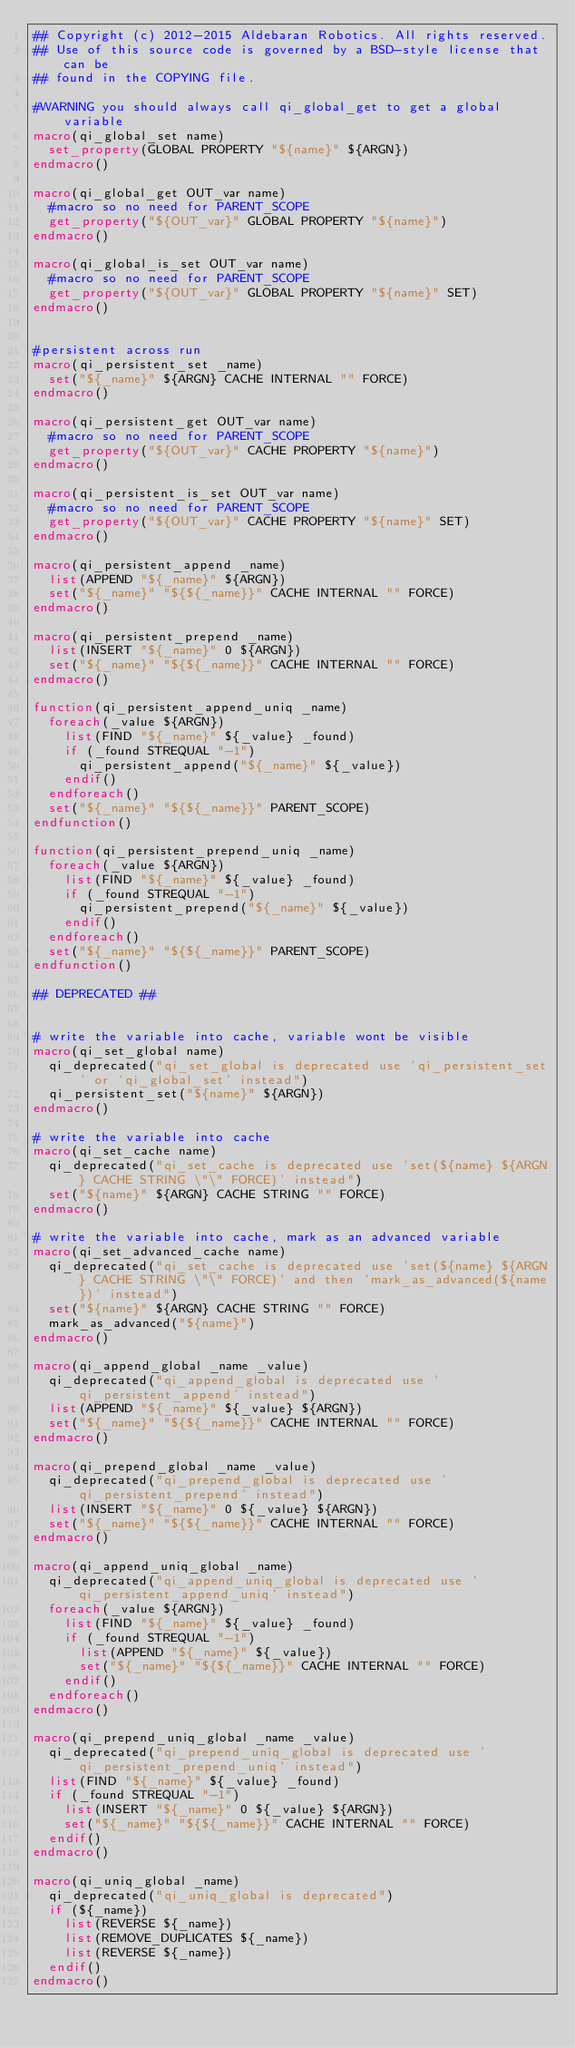<code> <loc_0><loc_0><loc_500><loc_500><_CMake_>## Copyright (c) 2012-2015 Aldebaran Robotics. All rights reserved.
## Use of this source code is governed by a BSD-style license that can be
## found in the COPYING file.

#WARNING you should always call qi_global_get to get a global variable
macro(qi_global_set name)
  set_property(GLOBAL PROPERTY "${name}" ${ARGN})
endmacro()

macro(qi_global_get OUT_var name)
  #macro so no need for PARENT_SCOPE
  get_property("${OUT_var}" GLOBAL PROPERTY "${name}")
endmacro()

macro(qi_global_is_set OUT_var name)
  #macro so no need for PARENT_SCOPE
  get_property("${OUT_var}" GLOBAL PROPERTY "${name}" SET)
endmacro()


#persistent across run
macro(qi_persistent_set _name)
  set("${_name}" ${ARGN} CACHE INTERNAL "" FORCE)
endmacro()

macro(qi_persistent_get OUT_var name)
  #macro so no need for PARENT_SCOPE
  get_property("${OUT_var}" CACHE PROPERTY "${name}")
endmacro()

macro(qi_persistent_is_set OUT_var name)
  #macro so no need for PARENT_SCOPE
  get_property("${OUT_var}" CACHE PROPERTY "${name}" SET)
endmacro()

macro(qi_persistent_append _name)
  list(APPEND "${_name}" ${ARGN})
  set("${_name}" "${${_name}}" CACHE INTERNAL "" FORCE)
endmacro()

macro(qi_persistent_prepend _name)
  list(INSERT "${_name}" 0 ${ARGN})
  set("${_name}" "${${_name}}" CACHE INTERNAL "" FORCE)
endmacro()

function(qi_persistent_append_uniq _name)
  foreach(_value ${ARGN})
    list(FIND "${_name}" ${_value} _found)
    if (_found STREQUAL "-1")
      qi_persistent_append("${_name}" ${_value})
    endif()
  endforeach()
  set("${_name}" "${${_name}}" PARENT_SCOPE)
endfunction()

function(qi_persistent_prepend_uniq _name)
  foreach(_value ${ARGN})
    list(FIND "${_name}" ${_value} _found)
    if (_found STREQUAL "-1")
      qi_persistent_prepend("${_name}" ${_value})
    endif()
  endforeach()
  set("${_name}" "${${_name}}" PARENT_SCOPE)
endfunction()

## DEPRECATED ##


# write the variable into cache, variable wont be visible
macro(qi_set_global name)
  qi_deprecated("qi_set_global is deprecated use 'qi_persistent_set' or 'qi_global_set' instead")
  qi_persistent_set("${name}" ${ARGN})
endmacro()

# write the variable into cache
macro(qi_set_cache name)
  qi_deprecated("qi_set_cache is deprecated use 'set(${name} ${ARGN} CACHE STRING \"\" FORCE)' instead")
  set("${name}" ${ARGN} CACHE STRING "" FORCE)
endmacro()

# write the variable into cache, mark as an advanced variable
macro(qi_set_advanced_cache name)
  qi_deprecated("qi_set_cache is deprecated use 'set(${name} ${ARGN} CACHE STRING \"\" FORCE)' and then 'mark_as_advanced(${name})' instead")
  set("${name}" ${ARGN} CACHE STRING "" FORCE)
  mark_as_advanced("${name}")
endmacro()

macro(qi_append_global _name _value)
  qi_deprecated("qi_append_global is deprecated use 'qi_persistent_append' instead")
  list(APPEND "${_name}" ${_value} ${ARGN})
  set("${_name}" "${${_name}}" CACHE INTERNAL "" FORCE)
endmacro()

macro(qi_prepend_global _name _value)
  qi_deprecated("qi_prepend_global is deprecated use 'qi_persistent_prepend' instead")
  list(INSERT "${_name}" 0 ${_value} ${ARGN})
  set("${_name}" "${${_name}}" CACHE INTERNAL "" FORCE)
endmacro()

macro(qi_append_uniq_global _name)
  qi_deprecated("qi_append_uniq_global is deprecated use 'qi_persistent_append_uniq' instead")
  foreach(_value ${ARGN})
    list(FIND "${_name}" ${_value} _found)
    if (_found STREQUAL "-1")
      list(APPEND "${_name}" ${_value})
      set("${_name}" "${${_name}}" CACHE INTERNAL "" FORCE)
    endif()
  endforeach()
endmacro()

macro(qi_prepend_uniq_global _name _value)
  qi_deprecated("qi_prepend_uniq_global is deprecated use 'qi_persistent_prepend_uniq' instead")
  list(FIND "${_name}" ${_value} _found)
  if (_found STREQUAL "-1")
    list(INSERT "${_name}" 0 ${_value} ${ARGN})
    set("${_name}" "${${_name}}" CACHE INTERNAL "" FORCE)
  endif()
endmacro()

macro(qi_uniq_global _name)
  qi_deprecated("qi_uniq_global is deprecated")
  if (${_name})
    list(REVERSE ${_name})
    list(REMOVE_DUPLICATES ${_name})
    list(REVERSE ${_name})
  endif()
endmacro()
</code> 